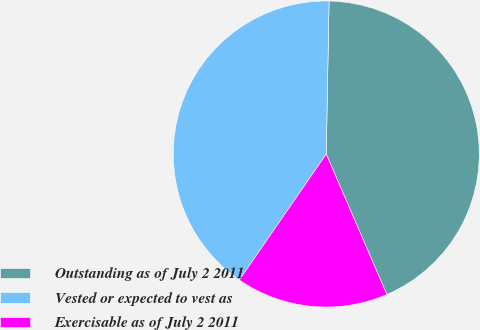Convert chart. <chart><loc_0><loc_0><loc_500><loc_500><pie_chart><fcel>Outstanding as of July 2 2011<fcel>Vested or expected to vest as<fcel>Exercisable as of July 2 2011<nl><fcel>43.22%<fcel>40.68%<fcel>16.09%<nl></chart> 